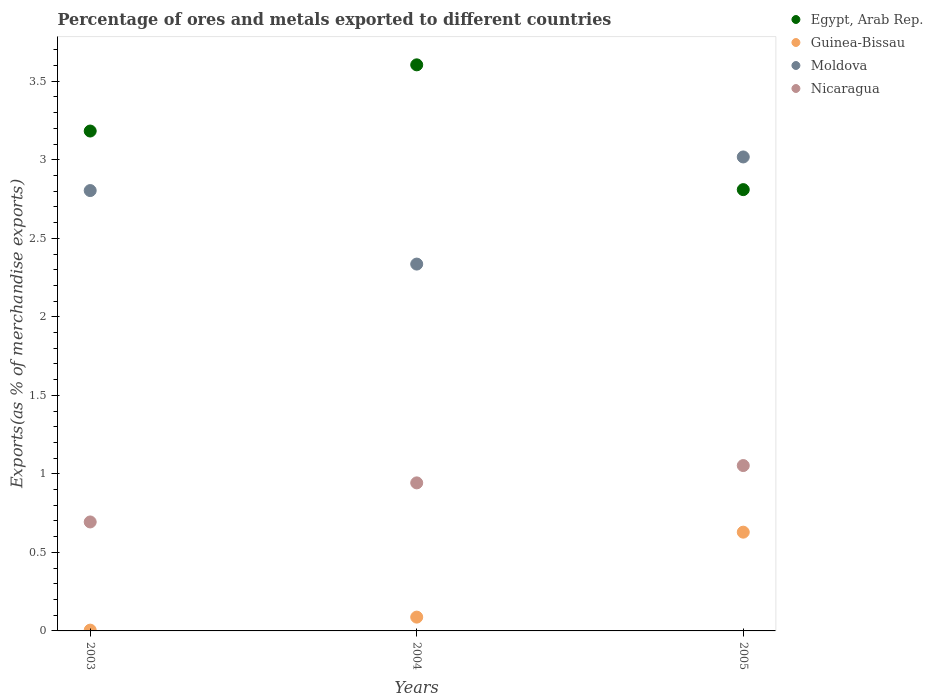How many different coloured dotlines are there?
Offer a terse response. 4. Is the number of dotlines equal to the number of legend labels?
Provide a succinct answer. Yes. What is the percentage of exports to different countries in Guinea-Bissau in 2004?
Your answer should be compact. 0.09. Across all years, what is the maximum percentage of exports to different countries in Nicaragua?
Give a very brief answer. 1.05. Across all years, what is the minimum percentage of exports to different countries in Guinea-Bissau?
Keep it short and to the point. 0.01. In which year was the percentage of exports to different countries in Moldova maximum?
Your answer should be very brief. 2005. In which year was the percentage of exports to different countries in Egypt, Arab Rep. minimum?
Offer a very short reply. 2005. What is the total percentage of exports to different countries in Egypt, Arab Rep. in the graph?
Make the answer very short. 9.6. What is the difference between the percentage of exports to different countries in Moldova in 2004 and that in 2005?
Offer a terse response. -0.68. What is the difference between the percentage of exports to different countries in Guinea-Bissau in 2004 and the percentage of exports to different countries in Moldova in 2005?
Give a very brief answer. -2.93. What is the average percentage of exports to different countries in Guinea-Bissau per year?
Your response must be concise. 0.24. In the year 2004, what is the difference between the percentage of exports to different countries in Nicaragua and percentage of exports to different countries in Egypt, Arab Rep.?
Your answer should be compact. -2.66. What is the ratio of the percentage of exports to different countries in Nicaragua in 2003 to that in 2004?
Ensure brevity in your answer.  0.74. What is the difference between the highest and the second highest percentage of exports to different countries in Guinea-Bissau?
Provide a succinct answer. 0.54. What is the difference between the highest and the lowest percentage of exports to different countries in Nicaragua?
Your answer should be compact. 0.36. Is it the case that in every year, the sum of the percentage of exports to different countries in Guinea-Bissau and percentage of exports to different countries in Egypt, Arab Rep.  is greater than the sum of percentage of exports to different countries in Nicaragua and percentage of exports to different countries in Moldova?
Your response must be concise. No. Is it the case that in every year, the sum of the percentage of exports to different countries in Guinea-Bissau and percentage of exports to different countries in Egypt, Arab Rep.  is greater than the percentage of exports to different countries in Moldova?
Ensure brevity in your answer.  Yes. Is the percentage of exports to different countries in Nicaragua strictly less than the percentage of exports to different countries in Egypt, Arab Rep. over the years?
Keep it short and to the point. Yes. Are the values on the major ticks of Y-axis written in scientific E-notation?
Provide a succinct answer. No. Does the graph contain any zero values?
Keep it short and to the point. No. Does the graph contain grids?
Ensure brevity in your answer.  No. Where does the legend appear in the graph?
Ensure brevity in your answer.  Top right. What is the title of the graph?
Your answer should be very brief. Percentage of ores and metals exported to different countries. What is the label or title of the X-axis?
Keep it short and to the point. Years. What is the label or title of the Y-axis?
Your response must be concise. Exports(as % of merchandise exports). What is the Exports(as % of merchandise exports) of Egypt, Arab Rep. in 2003?
Your answer should be very brief. 3.18. What is the Exports(as % of merchandise exports) in Guinea-Bissau in 2003?
Make the answer very short. 0.01. What is the Exports(as % of merchandise exports) of Moldova in 2003?
Your response must be concise. 2.8. What is the Exports(as % of merchandise exports) of Nicaragua in 2003?
Offer a very short reply. 0.69. What is the Exports(as % of merchandise exports) in Egypt, Arab Rep. in 2004?
Offer a terse response. 3.6. What is the Exports(as % of merchandise exports) in Guinea-Bissau in 2004?
Ensure brevity in your answer.  0.09. What is the Exports(as % of merchandise exports) of Moldova in 2004?
Provide a succinct answer. 2.34. What is the Exports(as % of merchandise exports) of Nicaragua in 2004?
Make the answer very short. 0.94. What is the Exports(as % of merchandise exports) in Egypt, Arab Rep. in 2005?
Your response must be concise. 2.81. What is the Exports(as % of merchandise exports) of Guinea-Bissau in 2005?
Your answer should be compact. 0.63. What is the Exports(as % of merchandise exports) in Moldova in 2005?
Provide a succinct answer. 3.02. What is the Exports(as % of merchandise exports) in Nicaragua in 2005?
Provide a succinct answer. 1.05. Across all years, what is the maximum Exports(as % of merchandise exports) of Egypt, Arab Rep.?
Offer a terse response. 3.6. Across all years, what is the maximum Exports(as % of merchandise exports) in Guinea-Bissau?
Your response must be concise. 0.63. Across all years, what is the maximum Exports(as % of merchandise exports) in Moldova?
Make the answer very short. 3.02. Across all years, what is the maximum Exports(as % of merchandise exports) in Nicaragua?
Your answer should be very brief. 1.05. Across all years, what is the minimum Exports(as % of merchandise exports) of Egypt, Arab Rep.?
Keep it short and to the point. 2.81. Across all years, what is the minimum Exports(as % of merchandise exports) of Guinea-Bissau?
Your answer should be very brief. 0.01. Across all years, what is the minimum Exports(as % of merchandise exports) in Moldova?
Provide a succinct answer. 2.34. Across all years, what is the minimum Exports(as % of merchandise exports) of Nicaragua?
Your answer should be compact. 0.69. What is the total Exports(as % of merchandise exports) in Egypt, Arab Rep. in the graph?
Provide a short and direct response. 9.6. What is the total Exports(as % of merchandise exports) in Guinea-Bissau in the graph?
Make the answer very short. 0.72. What is the total Exports(as % of merchandise exports) of Moldova in the graph?
Provide a succinct answer. 8.16. What is the total Exports(as % of merchandise exports) of Nicaragua in the graph?
Your response must be concise. 2.69. What is the difference between the Exports(as % of merchandise exports) in Egypt, Arab Rep. in 2003 and that in 2004?
Give a very brief answer. -0.42. What is the difference between the Exports(as % of merchandise exports) of Guinea-Bissau in 2003 and that in 2004?
Provide a short and direct response. -0.08. What is the difference between the Exports(as % of merchandise exports) of Moldova in 2003 and that in 2004?
Your answer should be very brief. 0.47. What is the difference between the Exports(as % of merchandise exports) of Nicaragua in 2003 and that in 2004?
Make the answer very short. -0.25. What is the difference between the Exports(as % of merchandise exports) in Egypt, Arab Rep. in 2003 and that in 2005?
Ensure brevity in your answer.  0.37. What is the difference between the Exports(as % of merchandise exports) of Guinea-Bissau in 2003 and that in 2005?
Offer a very short reply. -0.62. What is the difference between the Exports(as % of merchandise exports) in Moldova in 2003 and that in 2005?
Provide a succinct answer. -0.21. What is the difference between the Exports(as % of merchandise exports) of Nicaragua in 2003 and that in 2005?
Provide a succinct answer. -0.36. What is the difference between the Exports(as % of merchandise exports) in Egypt, Arab Rep. in 2004 and that in 2005?
Offer a very short reply. 0.79. What is the difference between the Exports(as % of merchandise exports) in Guinea-Bissau in 2004 and that in 2005?
Keep it short and to the point. -0.54. What is the difference between the Exports(as % of merchandise exports) in Moldova in 2004 and that in 2005?
Provide a succinct answer. -0.68. What is the difference between the Exports(as % of merchandise exports) of Nicaragua in 2004 and that in 2005?
Offer a very short reply. -0.11. What is the difference between the Exports(as % of merchandise exports) in Egypt, Arab Rep. in 2003 and the Exports(as % of merchandise exports) in Guinea-Bissau in 2004?
Ensure brevity in your answer.  3.1. What is the difference between the Exports(as % of merchandise exports) of Egypt, Arab Rep. in 2003 and the Exports(as % of merchandise exports) of Moldova in 2004?
Provide a short and direct response. 0.85. What is the difference between the Exports(as % of merchandise exports) of Egypt, Arab Rep. in 2003 and the Exports(as % of merchandise exports) of Nicaragua in 2004?
Give a very brief answer. 2.24. What is the difference between the Exports(as % of merchandise exports) in Guinea-Bissau in 2003 and the Exports(as % of merchandise exports) in Moldova in 2004?
Your answer should be compact. -2.33. What is the difference between the Exports(as % of merchandise exports) of Guinea-Bissau in 2003 and the Exports(as % of merchandise exports) of Nicaragua in 2004?
Ensure brevity in your answer.  -0.94. What is the difference between the Exports(as % of merchandise exports) in Moldova in 2003 and the Exports(as % of merchandise exports) in Nicaragua in 2004?
Make the answer very short. 1.86. What is the difference between the Exports(as % of merchandise exports) in Egypt, Arab Rep. in 2003 and the Exports(as % of merchandise exports) in Guinea-Bissau in 2005?
Offer a very short reply. 2.55. What is the difference between the Exports(as % of merchandise exports) of Egypt, Arab Rep. in 2003 and the Exports(as % of merchandise exports) of Moldova in 2005?
Give a very brief answer. 0.17. What is the difference between the Exports(as % of merchandise exports) in Egypt, Arab Rep. in 2003 and the Exports(as % of merchandise exports) in Nicaragua in 2005?
Your answer should be very brief. 2.13. What is the difference between the Exports(as % of merchandise exports) in Guinea-Bissau in 2003 and the Exports(as % of merchandise exports) in Moldova in 2005?
Keep it short and to the point. -3.01. What is the difference between the Exports(as % of merchandise exports) in Guinea-Bissau in 2003 and the Exports(as % of merchandise exports) in Nicaragua in 2005?
Your answer should be compact. -1.05. What is the difference between the Exports(as % of merchandise exports) of Moldova in 2003 and the Exports(as % of merchandise exports) of Nicaragua in 2005?
Your response must be concise. 1.75. What is the difference between the Exports(as % of merchandise exports) of Egypt, Arab Rep. in 2004 and the Exports(as % of merchandise exports) of Guinea-Bissau in 2005?
Your answer should be compact. 2.98. What is the difference between the Exports(as % of merchandise exports) in Egypt, Arab Rep. in 2004 and the Exports(as % of merchandise exports) in Moldova in 2005?
Your answer should be compact. 0.59. What is the difference between the Exports(as % of merchandise exports) in Egypt, Arab Rep. in 2004 and the Exports(as % of merchandise exports) in Nicaragua in 2005?
Ensure brevity in your answer.  2.55. What is the difference between the Exports(as % of merchandise exports) of Guinea-Bissau in 2004 and the Exports(as % of merchandise exports) of Moldova in 2005?
Your answer should be very brief. -2.93. What is the difference between the Exports(as % of merchandise exports) in Guinea-Bissau in 2004 and the Exports(as % of merchandise exports) in Nicaragua in 2005?
Provide a succinct answer. -0.97. What is the difference between the Exports(as % of merchandise exports) of Moldova in 2004 and the Exports(as % of merchandise exports) of Nicaragua in 2005?
Ensure brevity in your answer.  1.28. What is the average Exports(as % of merchandise exports) of Egypt, Arab Rep. per year?
Keep it short and to the point. 3.2. What is the average Exports(as % of merchandise exports) of Guinea-Bissau per year?
Keep it short and to the point. 0.24. What is the average Exports(as % of merchandise exports) in Moldova per year?
Provide a succinct answer. 2.72. What is the average Exports(as % of merchandise exports) in Nicaragua per year?
Offer a very short reply. 0.9. In the year 2003, what is the difference between the Exports(as % of merchandise exports) of Egypt, Arab Rep. and Exports(as % of merchandise exports) of Guinea-Bissau?
Ensure brevity in your answer.  3.18. In the year 2003, what is the difference between the Exports(as % of merchandise exports) in Egypt, Arab Rep. and Exports(as % of merchandise exports) in Moldova?
Keep it short and to the point. 0.38. In the year 2003, what is the difference between the Exports(as % of merchandise exports) in Egypt, Arab Rep. and Exports(as % of merchandise exports) in Nicaragua?
Give a very brief answer. 2.49. In the year 2003, what is the difference between the Exports(as % of merchandise exports) in Guinea-Bissau and Exports(as % of merchandise exports) in Moldova?
Offer a very short reply. -2.8. In the year 2003, what is the difference between the Exports(as % of merchandise exports) of Guinea-Bissau and Exports(as % of merchandise exports) of Nicaragua?
Give a very brief answer. -0.69. In the year 2003, what is the difference between the Exports(as % of merchandise exports) in Moldova and Exports(as % of merchandise exports) in Nicaragua?
Ensure brevity in your answer.  2.11. In the year 2004, what is the difference between the Exports(as % of merchandise exports) in Egypt, Arab Rep. and Exports(as % of merchandise exports) in Guinea-Bissau?
Give a very brief answer. 3.52. In the year 2004, what is the difference between the Exports(as % of merchandise exports) of Egypt, Arab Rep. and Exports(as % of merchandise exports) of Moldova?
Your answer should be compact. 1.27. In the year 2004, what is the difference between the Exports(as % of merchandise exports) of Egypt, Arab Rep. and Exports(as % of merchandise exports) of Nicaragua?
Give a very brief answer. 2.66. In the year 2004, what is the difference between the Exports(as % of merchandise exports) of Guinea-Bissau and Exports(as % of merchandise exports) of Moldova?
Ensure brevity in your answer.  -2.25. In the year 2004, what is the difference between the Exports(as % of merchandise exports) of Guinea-Bissau and Exports(as % of merchandise exports) of Nicaragua?
Provide a succinct answer. -0.85. In the year 2004, what is the difference between the Exports(as % of merchandise exports) in Moldova and Exports(as % of merchandise exports) in Nicaragua?
Your answer should be compact. 1.39. In the year 2005, what is the difference between the Exports(as % of merchandise exports) in Egypt, Arab Rep. and Exports(as % of merchandise exports) in Guinea-Bissau?
Provide a short and direct response. 2.18. In the year 2005, what is the difference between the Exports(as % of merchandise exports) in Egypt, Arab Rep. and Exports(as % of merchandise exports) in Moldova?
Your response must be concise. -0.21. In the year 2005, what is the difference between the Exports(as % of merchandise exports) in Egypt, Arab Rep. and Exports(as % of merchandise exports) in Nicaragua?
Give a very brief answer. 1.76. In the year 2005, what is the difference between the Exports(as % of merchandise exports) of Guinea-Bissau and Exports(as % of merchandise exports) of Moldova?
Provide a short and direct response. -2.39. In the year 2005, what is the difference between the Exports(as % of merchandise exports) of Guinea-Bissau and Exports(as % of merchandise exports) of Nicaragua?
Your response must be concise. -0.42. In the year 2005, what is the difference between the Exports(as % of merchandise exports) in Moldova and Exports(as % of merchandise exports) in Nicaragua?
Provide a short and direct response. 1.97. What is the ratio of the Exports(as % of merchandise exports) of Egypt, Arab Rep. in 2003 to that in 2004?
Your answer should be very brief. 0.88. What is the ratio of the Exports(as % of merchandise exports) of Guinea-Bissau in 2003 to that in 2004?
Your response must be concise. 0.06. What is the ratio of the Exports(as % of merchandise exports) in Moldova in 2003 to that in 2004?
Your answer should be compact. 1.2. What is the ratio of the Exports(as % of merchandise exports) of Nicaragua in 2003 to that in 2004?
Your response must be concise. 0.74. What is the ratio of the Exports(as % of merchandise exports) in Egypt, Arab Rep. in 2003 to that in 2005?
Your answer should be very brief. 1.13. What is the ratio of the Exports(as % of merchandise exports) in Guinea-Bissau in 2003 to that in 2005?
Your answer should be compact. 0.01. What is the ratio of the Exports(as % of merchandise exports) of Moldova in 2003 to that in 2005?
Keep it short and to the point. 0.93. What is the ratio of the Exports(as % of merchandise exports) in Nicaragua in 2003 to that in 2005?
Ensure brevity in your answer.  0.66. What is the ratio of the Exports(as % of merchandise exports) of Egypt, Arab Rep. in 2004 to that in 2005?
Offer a very short reply. 1.28. What is the ratio of the Exports(as % of merchandise exports) of Guinea-Bissau in 2004 to that in 2005?
Offer a terse response. 0.14. What is the ratio of the Exports(as % of merchandise exports) of Moldova in 2004 to that in 2005?
Make the answer very short. 0.77. What is the ratio of the Exports(as % of merchandise exports) of Nicaragua in 2004 to that in 2005?
Make the answer very short. 0.9. What is the difference between the highest and the second highest Exports(as % of merchandise exports) in Egypt, Arab Rep.?
Provide a short and direct response. 0.42. What is the difference between the highest and the second highest Exports(as % of merchandise exports) of Guinea-Bissau?
Make the answer very short. 0.54. What is the difference between the highest and the second highest Exports(as % of merchandise exports) in Moldova?
Provide a short and direct response. 0.21. What is the difference between the highest and the second highest Exports(as % of merchandise exports) in Nicaragua?
Give a very brief answer. 0.11. What is the difference between the highest and the lowest Exports(as % of merchandise exports) of Egypt, Arab Rep.?
Keep it short and to the point. 0.79. What is the difference between the highest and the lowest Exports(as % of merchandise exports) of Guinea-Bissau?
Offer a terse response. 0.62. What is the difference between the highest and the lowest Exports(as % of merchandise exports) of Moldova?
Make the answer very short. 0.68. What is the difference between the highest and the lowest Exports(as % of merchandise exports) of Nicaragua?
Provide a short and direct response. 0.36. 